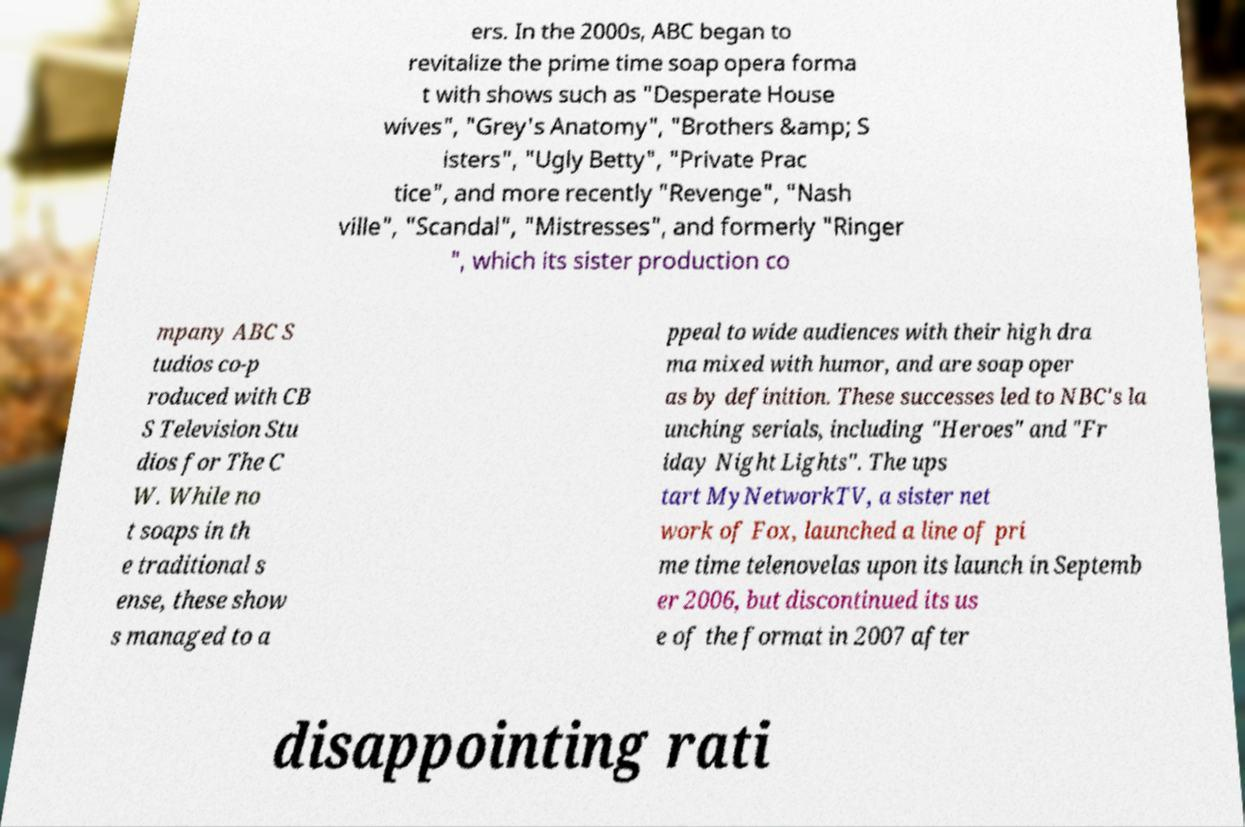What messages or text are displayed in this image? I need them in a readable, typed format. ers. In the 2000s, ABC began to revitalize the prime time soap opera forma t with shows such as "Desperate House wives", "Grey's Anatomy", "Brothers &amp; S isters", "Ugly Betty", "Private Prac tice", and more recently "Revenge", "Nash ville", "Scandal", "Mistresses", and formerly "Ringer ", which its sister production co mpany ABC S tudios co-p roduced with CB S Television Stu dios for The C W. While no t soaps in th e traditional s ense, these show s managed to a ppeal to wide audiences with their high dra ma mixed with humor, and are soap oper as by definition. These successes led to NBC's la unching serials, including "Heroes" and "Fr iday Night Lights". The ups tart MyNetworkTV, a sister net work of Fox, launched a line of pri me time telenovelas upon its launch in Septemb er 2006, but discontinued its us e of the format in 2007 after disappointing rati 